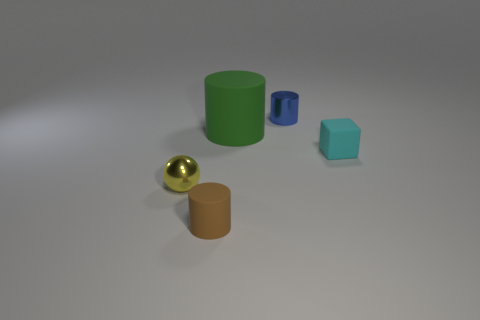Add 2 cyan rubber things. How many objects exist? 7 Subtract all cylinders. How many objects are left? 2 Add 5 large things. How many large things exist? 6 Subtract 0 gray cylinders. How many objects are left? 5 Subtract all big red shiny spheres. Subtract all small brown cylinders. How many objects are left? 4 Add 3 small blue metallic things. How many small blue metallic things are left? 4 